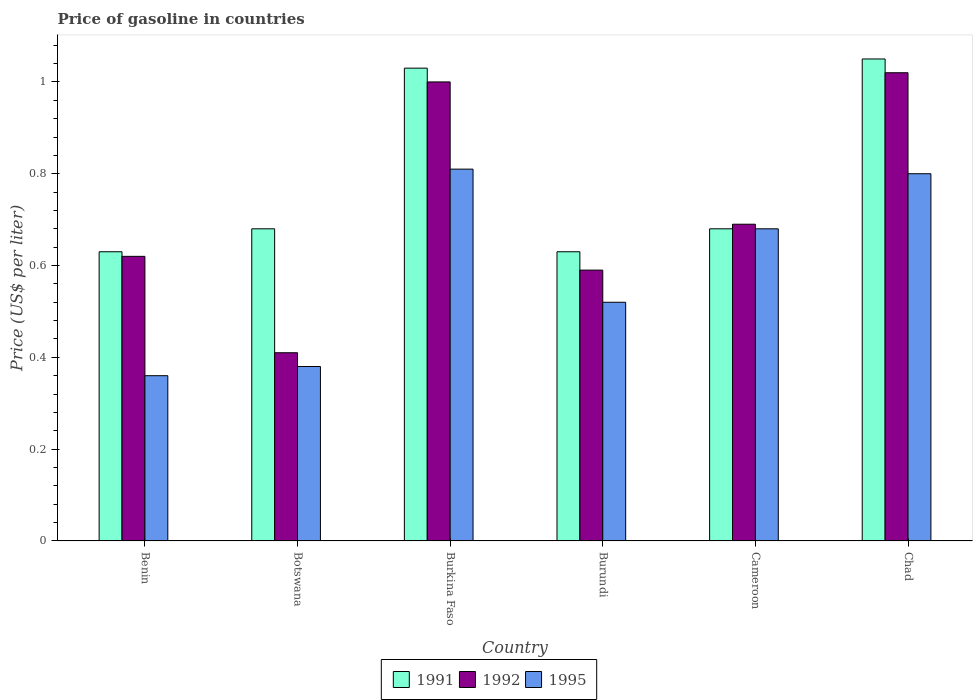How many different coloured bars are there?
Ensure brevity in your answer.  3. What is the label of the 3rd group of bars from the left?
Ensure brevity in your answer.  Burkina Faso. What is the price of gasoline in 1995 in Benin?
Offer a very short reply. 0.36. Across all countries, what is the minimum price of gasoline in 1991?
Offer a terse response. 0.63. In which country was the price of gasoline in 1995 maximum?
Ensure brevity in your answer.  Burkina Faso. In which country was the price of gasoline in 1991 minimum?
Make the answer very short. Benin. What is the total price of gasoline in 1995 in the graph?
Ensure brevity in your answer.  3.55. What is the difference between the price of gasoline in 1992 in Burkina Faso and that in Cameroon?
Offer a very short reply. 0.31. What is the difference between the price of gasoline in 1991 in Chad and the price of gasoline in 1995 in Burkina Faso?
Offer a very short reply. 0.24. What is the average price of gasoline in 1992 per country?
Your response must be concise. 0.72. What is the difference between the price of gasoline of/in 1991 and price of gasoline of/in 1995 in Benin?
Provide a succinct answer. 0.27. In how many countries, is the price of gasoline in 1995 greater than 1.04 US$?
Keep it short and to the point. 0. What is the ratio of the price of gasoline in 1995 in Botswana to that in Burundi?
Offer a very short reply. 0.73. Is the price of gasoline in 1992 in Botswana less than that in Burundi?
Your answer should be very brief. Yes. What is the difference between the highest and the second highest price of gasoline in 1991?
Keep it short and to the point. -0.37. What is the difference between the highest and the lowest price of gasoline in 1991?
Keep it short and to the point. 0.42. Is the sum of the price of gasoline in 1995 in Botswana and Chad greater than the maximum price of gasoline in 1992 across all countries?
Your response must be concise. Yes. What does the 1st bar from the left in Burkina Faso represents?
Provide a succinct answer. 1991. Is it the case that in every country, the sum of the price of gasoline in 1995 and price of gasoline in 1991 is greater than the price of gasoline in 1992?
Provide a succinct answer. Yes. How many bars are there?
Your answer should be compact. 18. Are the values on the major ticks of Y-axis written in scientific E-notation?
Keep it short and to the point. No. Where does the legend appear in the graph?
Provide a short and direct response. Bottom center. What is the title of the graph?
Provide a short and direct response. Price of gasoline in countries. Does "1991" appear as one of the legend labels in the graph?
Provide a short and direct response. Yes. What is the label or title of the Y-axis?
Offer a very short reply. Price (US$ per liter). What is the Price (US$ per liter) of 1991 in Benin?
Provide a succinct answer. 0.63. What is the Price (US$ per liter) of 1992 in Benin?
Keep it short and to the point. 0.62. What is the Price (US$ per liter) of 1995 in Benin?
Ensure brevity in your answer.  0.36. What is the Price (US$ per liter) in 1991 in Botswana?
Ensure brevity in your answer.  0.68. What is the Price (US$ per liter) in 1992 in Botswana?
Your response must be concise. 0.41. What is the Price (US$ per liter) of 1995 in Botswana?
Keep it short and to the point. 0.38. What is the Price (US$ per liter) in 1991 in Burkina Faso?
Your answer should be compact. 1.03. What is the Price (US$ per liter) in 1995 in Burkina Faso?
Your answer should be very brief. 0.81. What is the Price (US$ per liter) in 1991 in Burundi?
Make the answer very short. 0.63. What is the Price (US$ per liter) of 1992 in Burundi?
Ensure brevity in your answer.  0.59. What is the Price (US$ per liter) in 1995 in Burundi?
Provide a short and direct response. 0.52. What is the Price (US$ per liter) of 1991 in Cameroon?
Provide a succinct answer. 0.68. What is the Price (US$ per liter) in 1992 in Cameroon?
Your answer should be compact. 0.69. What is the Price (US$ per liter) of 1995 in Cameroon?
Your response must be concise. 0.68. What is the Price (US$ per liter) of 1995 in Chad?
Give a very brief answer. 0.8. Across all countries, what is the maximum Price (US$ per liter) of 1991?
Make the answer very short. 1.05. Across all countries, what is the maximum Price (US$ per liter) in 1995?
Provide a short and direct response. 0.81. Across all countries, what is the minimum Price (US$ per liter) of 1991?
Give a very brief answer. 0.63. Across all countries, what is the minimum Price (US$ per liter) in 1992?
Offer a terse response. 0.41. Across all countries, what is the minimum Price (US$ per liter) in 1995?
Make the answer very short. 0.36. What is the total Price (US$ per liter) in 1992 in the graph?
Keep it short and to the point. 4.33. What is the total Price (US$ per liter) of 1995 in the graph?
Your response must be concise. 3.55. What is the difference between the Price (US$ per liter) in 1992 in Benin and that in Botswana?
Make the answer very short. 0.21. What is the difference between the Price (US$ per liter) in 1995 in Benin and that in Botswana?
Provide a succinct answer. -0.02. What is the difference between the Price (US$ per liter) of 1991 in Benin and that in Burkina Faso?
Offer a very short reply. -0.4. What is the difference between the Price (US$ per liter) in 1992 in Benin and that in Burkina Faso?
Provide a short and direct response. -0.38. What is the difference between the Price (US$ per liter) in 1995 in Benin and that in Burkina Faso?
Offer a very short reply. -0.45. What is the difference between the Price (US$ per liter) of 1991 in Benin and that in Burundi?
Your response must be concise. 0. What is the difference between the Price (US$ per liter) in 1992 in Benin and that in Burundi?
Keep it short and to the point. 0.03. What is the difference between the Price (US$ per liter) of 1995 in Benin and that in Burundi?
Provide a succinct answer. -0.16. What is the difference between the Price (US$ per liter) in 1991 in Benin and that in Cameroon?
Ensure brevity in your answer.  -0.05. What is the difference between the Price (US$ per liter) in 1992 in Benin and that in Cameroon?
Ensure brevity in your answer.  -0.07. What is the difference between the Price (US$ per liter) of 1995 in Benin and that in Cameroon?
Keep it short and to the point. -0.32. What is the difference between the Price (US$ per liter) in 1991 in Benin and that in Chad?
Ensure brevity in your answer.  -0.42. What is the difference between the Price (US$ per liter) in 1995 in Benin and that in Chad?
Ensure brevity in your answer.  -0.44. What is the difference between the Price (US$ per liter) of 1991 in Botswana and that in Burkina Faso?
Your answer should be very brief. -0.35. What is the difference between the Price (US$ per liter) of 1992 in Botswana and that in Burkina Faso?
Offer a very short reply. -0.59. What is the difference between the Price (US$ per liter) of 1995 in Botswana and that in Burkina Faso?
Provide a short and direct response. -0.43. What is the difference between the Price (US$ per liter) of 1991 in Botswana and that in Burundi?
Ensure brevity in your answer.  0.05. What is the difference between the Price (US$ per liter) of 1992 in Botswana and that in Burundi?
Provide a short and direct response. -0.18. What is the difference between the Price (US$ per liter) of 1995 in Botswana and that in Burundi?
Make the answer very short. -0.14. What is the difference between the Price (US$ per liter) in 1991 in Botswana and that in Cameroon?
Provide a succinct answer. 0. What is the difference between the Price (US$ per liter) of 1992 in Botswana and that in Cameroon?
Your answer should be very brief. -0.28. What is the difference between the Price (US$ per liter) of 1991 in Botswana and that in Chad?
Provide a succinct answer. -0.37. What is the difference between the Price (US$ per liter) in 1992 in Botswana and that in Chad?
Make the answer very short. -0.61. What is the difference between the Price (US$ per liter) in 1995 in Botswana and that in Chad?
Give a very brief answer. -0.42. What is the difference between the Price (US$ per liter) in 1991 in Burkina Faso and that in Burundi?
Your response must be concise. 0.4. What is the difference between the Price (US$ per liter) in 1992 in Burkina Faso and that in Burundi?
Provide a succinct answer. 0.41. What is the difference between the Price (US$ per liter) of 1995 in Burkina Faso and that in Burundi?
Your response must be concise. 0.29. What is the difference between the Price (US$ per liter) of 1992 in Burkina Faso and that in Cameroon?
Offer a terse response. 0.31. What is the difference between the Price (US$ per liter) in 1995 in Burkina Faso and that in Cameroon?
Provide a succinct answer. 0.13. What is the difference between the Price (US$ per liter) of 1991 in Burkina Faso and that in Chad?
Your answer should be compact. -0.02. What is the difference between the Price (US$ per liter) of 1992 in Burkina Faso and that in Chad?
Your answer should be very brief. -0.02. What is the difference between the Price (US$ per liter) of 1991 in Burundi and that in Cameroon?
Offer a terse response. -0.05. What is the difference between the Price (US$ per liter) in 1992 in Burundi and that in Cameroon?
Your answer should be very brief. -0.1. What is the difference between the Price (US$ per liter) of 1995 in Burundi and that in Cameroon?
Your answer should be very brief. -0.16. What is the difference between the Price (US$ per liter) in 1991 in Burundi and that in Chad?
Your answer should be very brief. -0.42. What is the difference between the Price (US$ per liter) of 1992 in Burundi and that in Chad?
Provide a short and direct response. -0.43. What is the difference between the Price (US$ per liter) of 1995 in Burundi and that in Chad?
Make the answer very short. -0.28. What is the difference between the Price (US$ per liter) of 1991 in Cameroon and that in Chad?
Provide a short and direct response. -0.37. What is the difference between the Price (US$ per liter) of 1992 in Cameroon and that in Chad?
Your response must be concise. -0.33. What is the difference between the Price (US$ per liter) in 1995 in Cameroon and that in Chad?
Provide a short and direct response. -0.12. What is the difference between the Price (US$ per liter) in 1991 in Benin and the Price (US$ per liter) in 1992 in Botswana?
Offer a very short reply. 0.22. What is the difference between the Price (US$ per liter) of 1991 in Benin and the Price (US$ per liter) of 1995 in Botswana?
Ensure brevity in your answer.  0.25. What is the difference between the Price (US$ per liter) in 1992 in Benin and the Price (US$ per liter) in 1995 in Botswana?
Provide a succinct answer. 0.24. What is the difference between the Price (US$ per liter) in 1991 in Benin and the Price (US$ per liter) in 1992 in Burkina Faso?
Provide a short and direct response. -0.37. What is the difference between the Price (US$ per liter) of 1991 in Benin and the Price (US$ per liter) of 1995 in Burkina Faso?
Provide a short and direct response. -0.18. What is the difference between the Price (US$ per liter) in 1992 in Benin and the Price (US$ per liter) in 1995 in Burkina Faso?
Keep it short and to the point. -0.19. What is the difference between the Price (US$ per liter) in 1991 in Benin and the Price (US$ per liter) in 1992 in Burundi?
Keep it short and to the point. 0.04. What is the difference between the Price (US$ per liter) of 1991 in Benin and the Price (US$ per liter) of 1995 in Burundi?
Your answer should be very brief. 0.11. What is the difference between the Price (US$ per liter) in 1992 in Benin and the Price (US$ per liter) in 1995 in Burundi?
Provide a succinct answer. 0.1. What is the difference between the Price (US$ per liter) in 1991 in Benin and the Price (US$ per liter) in 1992 in Cameroon?
Ensure brevity in your answer.  -0.06. What is the difference between the Price (US$ per liter) in 1991 in Benin and the Price (US$ per liter) in 1995 in Cameroon?
Your response must be concise. -0.05. What is the difference between the Price (US$ per liter) of 1992 in Benin and the Price (US$ per liter) of 1995 in Cameroon?
Make the answer very short. -0.06. What is the difference between the Price (US$ per liter) in 1991 in Benin and the Price (US$ per liter) in 1992 in Chad?
Provide a short and direct response. -0.39. What is the difference between the Price (US$ per liter) of 1991 in Benin and the Price (US$ per liter) of 1995 in Chad?
Provide a short and direct response. -0.17. What is the difference between the Price (US$ per liter) of 1992 in Benin and the Price (US$ per liter) of 1995 in Chad?
Provide a short and direct response. -0.18. What is the difference between the Price (US$ per liter) of 1991 in Botswana and the Price (US$ per liter) of 1992 in Burkina Faso?
Provide a short and direct response. -0.32. What is the difference between the Price (US$ per liter) of 1991 in Botswana and the Price (US$ per liter) of 1995 in Burkina Faso?
Your answer should be compact. -0.13. What is the difference between the Price (US$ per liter) in 1991 in Botswana and the Price (US$ per liter) in 1992 in Burundi?
Keep it short and to the point. 0.09. What is the difference between the Price (US$ per liter) in 1991 in Botswana and the Price (US$ per liter) in 1995 in Burundi?
Give a very brief answer. 0.16. What is the difference between the Price (US$ per liter) in 1992 in Botswana and the Price (US$ per liter) in 1995 in Burundi?
Keep it short and to the point. -0.11. What is the difference between the Price (US$ per liter) in 1991 in Botswana and the Price (US$ per liter) in 1992 in Cameroon?
Give a very brief answer. -0.01. What is the difference between the Price (US$ per liter) of 1991 in Botswana and the Price (US$ per liter) of 1995 in Cameroon?
Offer a terse response. 0. What is the difference between the Price (US$ per liter) in 1992 in Botswana and the Price (US$ per liter) in 1995 in Cameroon?
Your answer should be compact. -0.27. What is the difference between the Price (US$ per liter) in 1991 in Botswana and the Price (US$ per liter) in 1992 in Chad?
Your response must be concise. -0.34. What is the difference between the Price (US$ per liter) of 1991 in Botswana and the Price (US$ per liter) of 1995 in Chad?
Your answer should be very brief. -0.12. What is the difference between the Price (US$ per liter) of 1992 in Botswana and the Price (US$ per liter) of 1995 in Chad?
Make the answer very short. -0.39. What is the difference between the Price (US$ per liter) of 1991 in Burkina Faso and the Price (US$ per liter) of 1992 in Burundi?
Make the answer very short. 0.44. What is the difference between the Price (US$ per liter) in 1991 in Burkina Faso and the Price (US$ per liter) in 1995 in Burundi?
Your response must be concise. 0.51. What is the difference between the Price (US$ per liter) in 1992 in Burkina Faso and the Price (US$ per liter) in 1995 in Burundi?
Provide a short and direct response. 0.48. What is the difference between the Price (US$ per liter) in 1991 in Burkina Faso and the Price (US$ per liter) in 1992 in Cameroon?
Provide a succinct answer. 0.34. What is the difference between the Price (US$ per liter) in 1991 in Burkina Faso and the Price (US$ per liter) in 1995 in Cameroon?
Give a very brief answer. 0.35. What is the difference between the Price (US$ per liter) of 1992 in Burkina Faso and the Price (US$ per liter) of 1995 in Cameroon?
Offer a very short reply. 0.32. What is the difference between the Price (US$ per liter) in 1991 in Burkina Faso and the Price (US$ per liter) in 1995 in Chad?
Keep it short and to the point. 0.23. What is the difference between the Price (US$ per liter) of 1991 in Burundi and the Price (US$ per liter) of 1992 in Cameroon?
Offer a terse response. -0.06. What is the difference between the Price (US$ per liter) of 1991 in Burundi and the Price (US$ per liter) of 1995 in Cameroon?
Keep it short and to the point. -0.05. What is the difference between the Price (US$ per liter) in 1992 in Burundi and the Price (US$ per liter) in 1995 in Cameroon?
Your answer should be compact. -0.09. What is the difference between the Price (US$ per liter) of 1991 in Burundi and the Price (US$ per liter) of 1992 in Chad?
Your answer should be compact. -0.39. What is the difference between the Price (US$ per liter) of 1991 in Burundi and the Price (US$ per liter) of 1995 in Chad?
Ensure brevity in your answer.  -0.17. What is the difference between the Price (US$ per liter) of 1992 in Burundi and the Price (US$ per liter) of 1995 in Chad?
Keep it short and to the point. -0.21. What is the difference between the Price (US$ per liter) of 1991 in Cameroon and the Price (US$ per liter) of 1992 in Chad?
Keep it short and to the point. -0.34. What is the difference between the Price (US$ per liter) of 1991 in Cameroon and the Price (US$ per liter) of 1995 in Chad?
Offer a terse response. -0.12. What is the difference between the Price (US$ per liter) in 1992 in Cameroon and the Price (US$ per liter) in 1995 in Chad?
Your answer should be very brief. -0.11. What is the average Price (US$ per liter) of 1991 per country?
Ensure brevity in your answer.  0.78. What is the average Price (US$ per liter) of 1992 per country?
Make the answer very short. 0.72. What is the average Price (US$ per liter) in 1995 per country?
Your answer should be compact. 0.59. What is the difference between the Price (US$ per liter) of 1991 and Price (US$ per liter) of 1995 in Benin?
Offer a very short reply. 0.27. What is the difference between the Price (US$ per liter) in 1992 and Price (US$ per liter) in 1995 in Benin?
Your answer should be compact. 0.26. What is the difference between the Price (US$ per liter) in 1991 and Price (US$ per liter) in 1992 in Botswana?
Your answer should be very brief. 0.27. What is the difference between the Price (US$ per liter) of 1991 and Price (US$ per liter) of 1995 in Botswana?
Your response must be concise. 0.3. What is the difference between the Price (US$ per liter) of 1992 and Price (US$ per liter) of 1995 in Botswana?
Give a very brief answer. 0.03. What is the difference between the Price (US$ per liter) in 1991 and Price (US$ per liter) in 1995 in Burkina Faso?
Offer a terse response. 0.22. What is the difference between the Price (US$ per liter) of 1992 and Price (US$ per liter) of 1995 in Burkina Faso?
Your response must be concise. 0.19. What is the difference between the Price (US$ per liter) of 1991 and Price (US$ per liter) of 1992 in Burundi?
Provide a succinct answer. 0.04. What is the difference between the Price (US$ per liter) of 1991 and Price (US$ per liter) of 1995 in Burundi?
Your response must be concise. 0.11. What is the difference between the Price (US$ per liter) of 1992 and Price (US$ per liter) of 1995 in Burundi?
Your answer should be compact. 0.07. What is the difference between the Price (US$ per liter) of 1991 and Price (US$ per liter) of 1992 in Cameroon?
Make the answer very short. -0.01. What is the difference between the Price (US$ per liter) of 1991 and Price (US$ per liter) of 1995 in Cameroon?
Offer a terse response. 0. What is the difference between the Price (US$ per liter) in 1991 and Price (US$ per liter) in 1995 in Chad?
Provide a short and direct response. 0.25. What is the difference between the Price (US$ per liter) in 1992 and Price (US$ per liter) in 1995 in Chad?
Your answer should be very brief. 0.22. What is the ratio of the Price (US$ per liter) in 1991 in Benin to that in Botswana?
Offer a terse response. 0.93. What is the ratio of the Price (US$ per liter) of 1992 in Benin to that in Botswana?
Your response must be concise. 1.51. What is the ratio of the Price (US$ per liter) of 1995 in Benin to that in Botswana?
Give a very brief answer. 0.95. What is the ratio of the Price (US$ per liter) of 1991 in Benin to that in Burkina Faso?
Offer a very short reply. 0.61. What is the ratio of the Price (US$ per liter) of 1992 in Benin to that in Burkina Faso?
Provide a short and direct response. 0.62. What is the ratio of the Price (US$ per liter) in 1995 in Benin to that in Burkina Faso?
Provide a succinct answer. 0.44. What is the ratio of the Price (US$ per liter) in 1991 in Benin to that in Burundi?
Your answer should be very brief. 1. What is the ratio of the Price (US$ per liter) in 1992 in Benin to that in Burundi?
Ensure brevity in your answer.  1.05. What is the ratio of the Price (US$ per liter) in 1995 in Benin to that in Burundi?
Offer a terse response. 0.69. What is the ratio of the Price (US$ per liter) of 1991 in Benin to that in Cameroon?
Ensure brevity in your answer.  0.93. What is the ratio of the Price (US$ per liter) in 1992 in Benin to that in Cameroon?
Offer a very short reply. 0.9. What is the ratio of the Price (US$ per liter) in 1995 in Benin to that in Cameroon?
Give a very brief answer. 0.53. What is the ratio of the Price (US$ per liter) in 1992 in Benin to that in Chad?
Your answer should be compact. 0.61. What is the ratio of the Price (US$ per liter) in 1995 in Benin to that in Chad?
Give a very brief answer. 0.45. What is the ratio of the Price (US$ per liter) in 1991 in Botswana to that in Burkina Faso?
Keep it short and to the point. 0.66. What is the ratio of the Price (US$ per liter) of 1992 in Botswana to that in Burkina Faso?
Your answer should be very brief. 0.41. What is the ratio of the Price (US$ per liter) in 1995 in Botswana to that in Burkina Faso?
Keep it short and to the point. 0.47. What is the ratio of the Price (US$ per liter) in 1991 in Botswana to that in Burundi?
Your answer should be very brief. 1.08. What is the ratio of the Price (US$ per liter) in 1992 in Botswana to that in Burundi?
Ensure brevity in your answer.  0.69. What is the ratio of the Price (US$ per liter) of 1995 in Botswana to that in Burundi?
Keep it short and to the point. 0.73. What is the ratio of the Price (US$ per liter) of 1991 in Botswana to that in Cameroon?
Your answer should be very brief. 1. What is the ratio of the Price (US$ per liter) in 1992 in Botswana to that in Cameroon?
Your answer should be compact. 0.59. What is the ratio of the Price (US$ per liter) of 1995 in Botswana to that in Cameroon?
Make the answer very short. 0.56. What is the ratio of the Price (US$ per liter) in 1991 in Botswana to that in Chad?
Make the answer very short. 0.65. What is the ratio of the Price (US$ per liter) in 1992 in Botswana to that in Chad?
Provide a short and direct response. 0.4. What is the ratio of the Price (US$ per liter) of 1995 in Botswana to that in Chad?
Offer a terse response. 0.47. What is the ratio of the Price (US$ per liter) of 1991 in Burkina Faso to that in Burundi?
Keep it short and to the point. 1.63. What is the ratio of the Price (US$ per liter) of 1992 in Burkina Faso to that in Burundi?
Your answer should be very brief. 1.69. What is the ratio of the Price (US$ per liter) of 1995 in Burkina Faso to that in Burundi?
Provide a short and direct response. 1.56. What is the ratio of the Price (US$ per liter) of 1991 in Burkina Faso to that in Cameroon?
Provide a succinct answer. 1.51. What is the ratio of the Price (US$ per liter) in 1992 in Burkina Faso to that in Cameroon?
Your answer should be very brief. 1.45. What is the ratio of the Price (US$ per liter) in 1995 in Burkina Faso to that in Cameroon?
Offer a terse response. 1.19. What is the ratio of the Price (US$ per liter) of 1991 in Burkina Faso to that in Chad?
Give a very brief answer. 0.98. What is the ratio of the Price (US$ per liter) of 1992 in Burkina Faso to that in Chad?
Ensure brevity in your answer.  0.98. What is the ratio of the Price (US$ per liter) in 1995 in Burkina Faso to that in Chad?
Your answer should be compact. 1.01. What is the ratio of the Price (US$ per liter) in 1991 in Burundi to that in Cameroon?
Your response must be concise. 0.93. What is the ratio of the Price (US$ per liter) of 1992 in Burundi to that in Cameroon?
Your answer should be compact. 0.86. What is the ratio of the Price (US$ per liter) in 1995 in Burundi to that in Cameroon?
Make the answer very short. 0.76. What is the ratio of the Price (US$ per liter) in 1991 in Burundi to that in Chad?
Provide a succinct answer. 0.6. What is the ratio of the Price (US$ per liter) in 1992 in Burundi to that in Chad?
Your response must be concise. 0.58. What is the ratio of the Price (US$ per liter) in 1995 in Burundi to that in Chad?
Provide a succinct answer. 0.65. What is the ratio of the Price (US$ per liter) in 1991 in Cameroon to that in Chad?
Your response must be concise. 0.65. What is the ratio of the Price (US$ per liter) in 1992 in Cameroon to that in Chad?
Offer a very short reply. 0.68. What is the difference between the highest and the second highest Price (US$ per liter) in 1991?
Your answer should be very brief. 0.02. What is the difference between the highest and the second highest Price (US$ per liter) of 1995?
Your response must be concise. 0.01. What is the difference between the highest and the lowest Price (US$ per liter) in 1991?
Your answer should be compact. 0.42. What is the difference between the highest and the lowest Price (US$ per liter) of 1992?
Give a very brief answer. 0.61. What is the difference between the highest and the lowest Price (US$ per liter) in 1995?
Give a very brief answer. 0.45. 